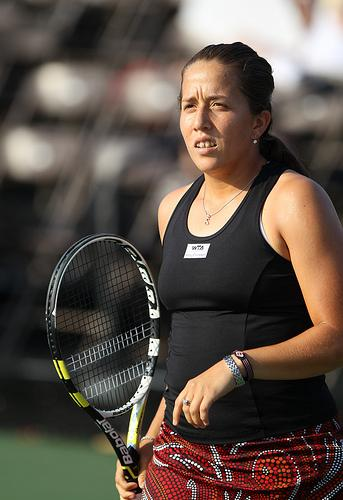Present a concise account of the primary subject in the picture, mentioning their apparel, accessories, and current activity. The main subject is a brown-haired woman holding a tennis racket, wearing a black shirt, plaid dress, and accessories like a watch, bracelets, necklace, earrings, and a ring. Quickly describe the central person in the image, including their outfit, embellishments, and the activity they are involved in. A woman with brown hair holds a tennis racket and is dressed in a black shirt and plaid dress, wearing accessories like a watch, bracelets, necklace, earrings, and a ring. Provide a brief overview of the key elements in the image, highlighting the central figure and their actions. The image features a brown-haired woman holding a tennis racket, dressed in a black shirt and plaid dress, and adorned with a watch, bracelets, a necklace, and other accessories. Briefly depict the core subject in the image, along with their outfit, accessories, and the action they are engaged in. A brown-haired woman stylishly grasps a tennis racket while attired in a black shirt, a plaid dress, and elegantly adorned with a watch, bracelets, a necklace, earrings, and an engagement ring. Offer a succinct description of the main subject in the photo, touching on their appearance, attire, accessories, and actions. The photo showcases a brown-haired woman with a tennis racket, dressed in a black shirt and a plaid dress, and wearing a watch, bracelets, a necklace, earrings, and a ring. Summarize the primary aspects of the image, with a focus on the central character, their clothing, adornments, and activities. The image centers on a brown-haired woman holding a tennis racket, attired in a black shirt and plaid dress, and decorated with various accessories like a watch, bracelets, a necklace, earrings, and a ring. Write a short narrative of the core subject in the image, including their attire, accessories, and activity. A woman with brown hair gracefully holds a yellow and black tennis racket, while donning a stylish black shirt, plaid dress, and various fashionable accessories such as a watch, bracelets, and a necklace. Identify the main object in the image and describe its appearance and activity. A woman with brown hair is holding a yellow and black tennis racket, wearing a black shirt and a plaid dress, as well as various accessories, such as a wristwatch, bracelets, and a necklace. Give a short and to-the-point description of the central figure in the image, including their activity, attire, and adornments. Woman with brown hair holding tennis racket, wearing black shirt, plaid dress, and accessories such as watch, bracelets, necklace, earrings, and ring. List the main aspects of the image, focusing on the prominent figure, their clothing, accessories, and actions. Brown-haired woman, holding a tennis racket, black shirt, plaid dress, wristwatch, bracelets, necklace, earrings, engagement ring. 